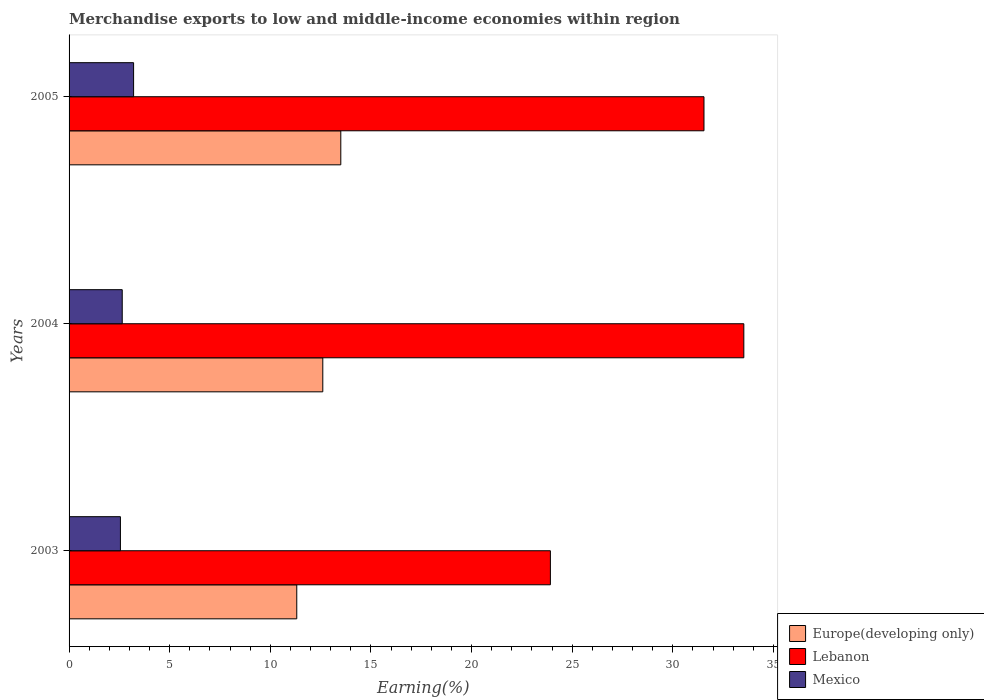How many different coloured bars are there?
Ensure brevity in your answer.  3. How many groups of bars are there?
Offer a terse response. 3. How many bars are there on the 1st tick from the top?
Your response must be concise. 3. How many bars are there on the 3rd tick from the bottom?
Your response must be concise. 3. What is the label of the 2nd group of bars from the top?
Give a very brief answer. 2004. What is the percentage of amount earned from merchandise exports in Mexico in 2004?
Offer a very short reply. 2.64. Across all years, what is the maximum percentage of amount earned from merchandise exports in Mexico?
Provide a succinct answer. 3.21. Across all years, what is the minimum percentage of amount earned from merchandise exports in Europe(developing only)?
Make the answer very short. 11.31. What is the total percentage of amount earned from merchandise exports in Lebanon in the graph?
Make the answer very short. 88.99. What is the difference between the percentage of amount earned from merchandise exports in Europe(developing only) in 2003 and that in 2005?
Your answer should be very brief. -2.19. What is the difference between the percentage of amount earned from merchandise exports in Lebanon in 2005 and the percentage of amount earned from merchandise exports in Europe(developing only) in 2003?
Offer a terse response. 20.24. What is the average percentage of amount earned from merchandise exports in Lebanon per year?
Offer a very short reply. 29.66. In the year 2003, what is the difference between the percentage of amount earned from merchandise exports in Mexico and percentage of amount earned from merchandise exports in Lebanon?
Your answer should be compact. -21.37. In how many years, is the percentage of amount earned from merchandise exports in Mexico greater than 32 %?
Ensure brevity in your answer.  0. What is the ratio of the percentage of amount earned from merchandise exports in Europe(developing only) in 2003 to that in 2005?
Offer a terse response. 0.84. What is the difference between the highest and the second highest percentage of amount earned from merchandise exports in Lebanon?
Ensure brevity in your answer.  1.98. What is the difference between the highest and the lowest percentage of amount earned from merchandise exports in Europe(developing only)?
Give a very brief answer. 2.19. In how many years, is the percentage of amount earned from merchandise exports in Lebanon greater than the average percentage of amount earned from merchandise exports in Lebanon taken over all years?
Your answer should be very brief. 2. What does the 1st bar from the top in 2003 represents?
Keep it short and to the point. Mexico. What does the 3rd bar from the bottom in 2005 represents?
Offer a very short reply. Mexico. Is it the case that in every year, the sum of the percentage of amount earned from merchandise exports in Mexico and percentage of amount earned from merchandise exports in Lebanon is greater than the percentage of amount earned from merchandise exports in Europe(developing only)?
Ensure brevity in your answer.  Yes. Are all the bars in the graph horizontal?
Give a very brief answer. Yes. How many years are there in the graph?
Keep it short and to the point. 3. What is the difference between two consecutive major ticks on the X-axis?
Your answer should be compact. 5. Are the values on the major ticks of X-axis written in scientific E-notation?
Ensure brevity in your answer.  No. Does the graph contain any zero values?
Your answer should be compact. No. Where does the legend appear in the graph?
Provide a succinct answer. Bottom right. How are the legend labels stacked?
Provide a succinct answer. Vertical. What is the title of the graph?
Offer a terse response. Merchandise exports to low and middle-income economies within region. Does "Maldives" appear as one of the legend labels in the graph?
Provide a short and direct response. No. What is the label or title of the X-axis?
Give a very brief answer. Earning(%). What is the label or title of the Y-axis?
Offer a very short reply. Years. What is the Earning(%) of Europe(developing only) in 2003?
Your response must be concise. 11.31. What is the Earning(%) of Lebanon in 2003?
Your answer should be compact. 23.92. What is the Earning(%) in Mexico in 2003?
Your answer should be very brief. 2.55. What is the Earning(%) in Europe(developing only) in 2004?
Ensure brevity in your answer.  12.61. What is the Earning(%) of Lebanon in 2004?
Your answer should be compact. 33.53. What is the Earning(%) of Mexico in 2004?
Keep it short and to the point. 2.64. What is the Earning(%) of Europe(developing only) in 2005?
Give a very brief answer. 13.5. What is the Earning(%) of Lebanon in 2005?
Your answer should be very brief. 31.55. What is the Earning(%) in Mexico in 2005?
Offer a very short reply. 3.21. Across all years, what is the maximum Earning(%) of Europe(developing only)?
Make the answer very short. 13.5. Across all years, what is the maximum Earning(%) of Lebanon?
Give a very brief answer. 33.53. Across all years, what is the maximum Earning(%) in Mexico?
Ensure brevity in your answer.  3.21. Across all years, what is the minimum Earning(%) of Europe(developing only)?
Your response must be concise. 11.31. Across all years, what is the minimum Earning(%) of Lebanon?
Provide a short and direct response. 23.92. Across all years, what is the minimum Earning(%) of Mexico?
Make the answer very short. 2.55. What is the total Earning(%) in Europe(developing only) in the graph?
Your answer should be very brief. 37.42. What is the total Earning(%) in Lebanon in the graph?
Ensure brevity in your answer.  88.99. What is the total Earning(%) in Mexico in the graph?
Provide a short and direct response. 8.4. What is the difference between the Earning(%) of Europe(developing only) in 2003 and that in 2004?
Give a very brief answer. -1.29. What is the difference between the Earning(%) of Lebanon in 2003 and that in 2004?
Your answer should be compact. -9.61. What is the difference between the Earning(%) in Mexico in 2003 and that in 2004?
Make the answer very short. -0.09. What is the difference between the Earning(%) in Europe(developing only) in 2003 and that in 2005?
Your answer should be very brief. -2.19. What is the difference between the Earning(%) of Lebanon in 2003 and that in 2005?
Provide a succinct answer. -7.63. What is the difference between the Earning(%) of Mexico in 2003 and that in 2005?
Offer a very short reply. -0.65. What is the difference between the Earning(%) of Europe(developing only) in 2004 and that in 2005?
Provide a short and direct response. -0.89. What is the difference between the Earning(%) in Lebanon in 2004 and that in 2005?
Provide a succinct answer. 1.98. What is the difference between the Earning(%) in Mexico in 2004 and that in 2005?
Provide a short and direct response. -0.56. What is the difference between the Earning(%) in Europe(developing only) in 2003 and the Earning(%) in Lebanon in 2004?
Ensure brevity in your answer.  -22.21. What is the difference between the Earning(%) of Europe(developing only) in 2003 and the Earning(%) of Mexico in 2004?
Make the answer very short. 8.67. What is the difference between the Earning(%) of Lebanon in 2003 and the Earning(%) of Mexico in 2004?
Your answer should be very brief. 21.27. What is the difference between the Earning(%) of Europe(developing only) in 2003 and the Earning(%) of Lebanon in 2005?
Give a very brief answer. -20.24. What is the difference between the Earning(%) in Europe(developing only) in 2003 and the Earning(%) in Mexico in 2005?
Provide a succinct answer. 8.11. What is the difference between the Earning(%) in Lebanon in 2003 and the Earning(%) in Mexico in 2005?
Give a very brief answer. 20.71. What is the difference between the Earning(%) in Europe(developing only) in 2004 and the Earning(%) in Lebanon in 2005?
Ensure brevity in your answer.  -18.94. What is the difference between the Earning(%) in Europe(developing only) in 2004 and the Earning(%) in Mexico in 2005?
Your answer should be compact. 9.4. What is the difference between the Earning(%) in Lebanon in 2004 and the Earning(%) in Mexico in 2005?
Provide a short and direct response. 30.32. What is the average Earning(%) of Europe(developing only) per year?
Ensure brevity in your answer.  12.47. What is the average Earning(%) in Lebanon per year?
Your answer should be very brief. 29.66. What is the average Earning(%) in Mexico per year?
Your answer should be compact. 2.8. In the year 2003, what is the difference between the Earning(%) in Europe(developing only) and Earning(%) in Lebanon?
Keep it short and to the point. -12.6. In the year 2003, what is the difference between the Earning(%) of Europe(developing only) and Earning(%) of Mexico?
Your answer should be very brief. 8.76. In the year 2003, what is the difference between the Earning(%) of Lebanon and Earning(%) of Mexico?
Give a very brief answer. 21.37. In the year 2004, what is the difference between the Earning(%) in Europe(developing only) and Earning(%) in Lebanon?
Make the answer very short. -20.92. In the year 2004, what is the difference between the Earning(%) of Europe(developing only) and Earning(%) of Mexico?
Provide a succinct answer. 9.97. In the year 2004, what is the difference between the Earning(%) in Lebanon and Earning(%) in Mexico?
Provide a succinct answer. 30.89. In the year 2005, what is the difference between the Earning(%) in Europe(developing only) and Earning(%) in Lebanon?
Offer a very short reply. -18.05. In the year 2005, what is the difference between the Earning(%) in Europe(developing only) and Earning(%) in Mexico?
Offer a terse response. 10.3. In the year 2005, what is the difference between the Earning(%) in Lebanon and Earning(%) in Mexico?
Offer a terse response. 28.34. What is the ratio of the Earning(%) of Europe(developing only) in 2003 to that in 2004?
Offer a very short reply. 0.9. What is the ratio of the Earning(%) in Lebanon in 2003 to that in 2004?
Your answer should be very brief. 0.71. What is the ratio of the Earning(%) in Mexico in 2003 to that in 2004?
Keep it short and to the point. 0.97. What is the ratio of the Earning(%) in Europe(developing only) in 2003 to that in 2005?
Provide a short and direct response. 0.84. What is the ratio of the Earning(%) in Lebanon in 2003 to that in 2005?
Give a very brief answer. 0.76. What is the ratio of the Earning(%) of Mexico in 2003 to that in 2005?
Provide a short and direct response. 0.8. What is the ratio of the Earning(%) of Europe(developing only) in 2004 to that in 2005?
Provide a succinct answer. 0.93. What is the ratio of the Earning(%) of Lebanon in 2004 to that in 2005?
Give a very brief answer. 1.06. What is the ratio of the Earning(%) in Mexico in 2004 to that in 2005?
Your answer should be very brief. 0.82. What is the difference between the highest and the second highest Earning(%) of Europe(developing only)?
Ensure brevity in your answer.  0.89. What is the difference between the highest and the second highest Earning(%) of Lebanon?
Offer a very short reply. 1.98. What is the difference between the highest and the second highest Earning(%) of Mexico?
Keep it short and to the point. 0.56. What is the difference between the highest and the lowest Earning(%) in Europe(developing only)?
Your response must be concise. 2.19. What is the difference between the highest and the lowest Earning(%) of Lebanon?
Your answer should be very brief. 9.61. What is the difference between the highest and the lowest Earning(%) of Mexico?
Give a very brief answer. 0.65. 